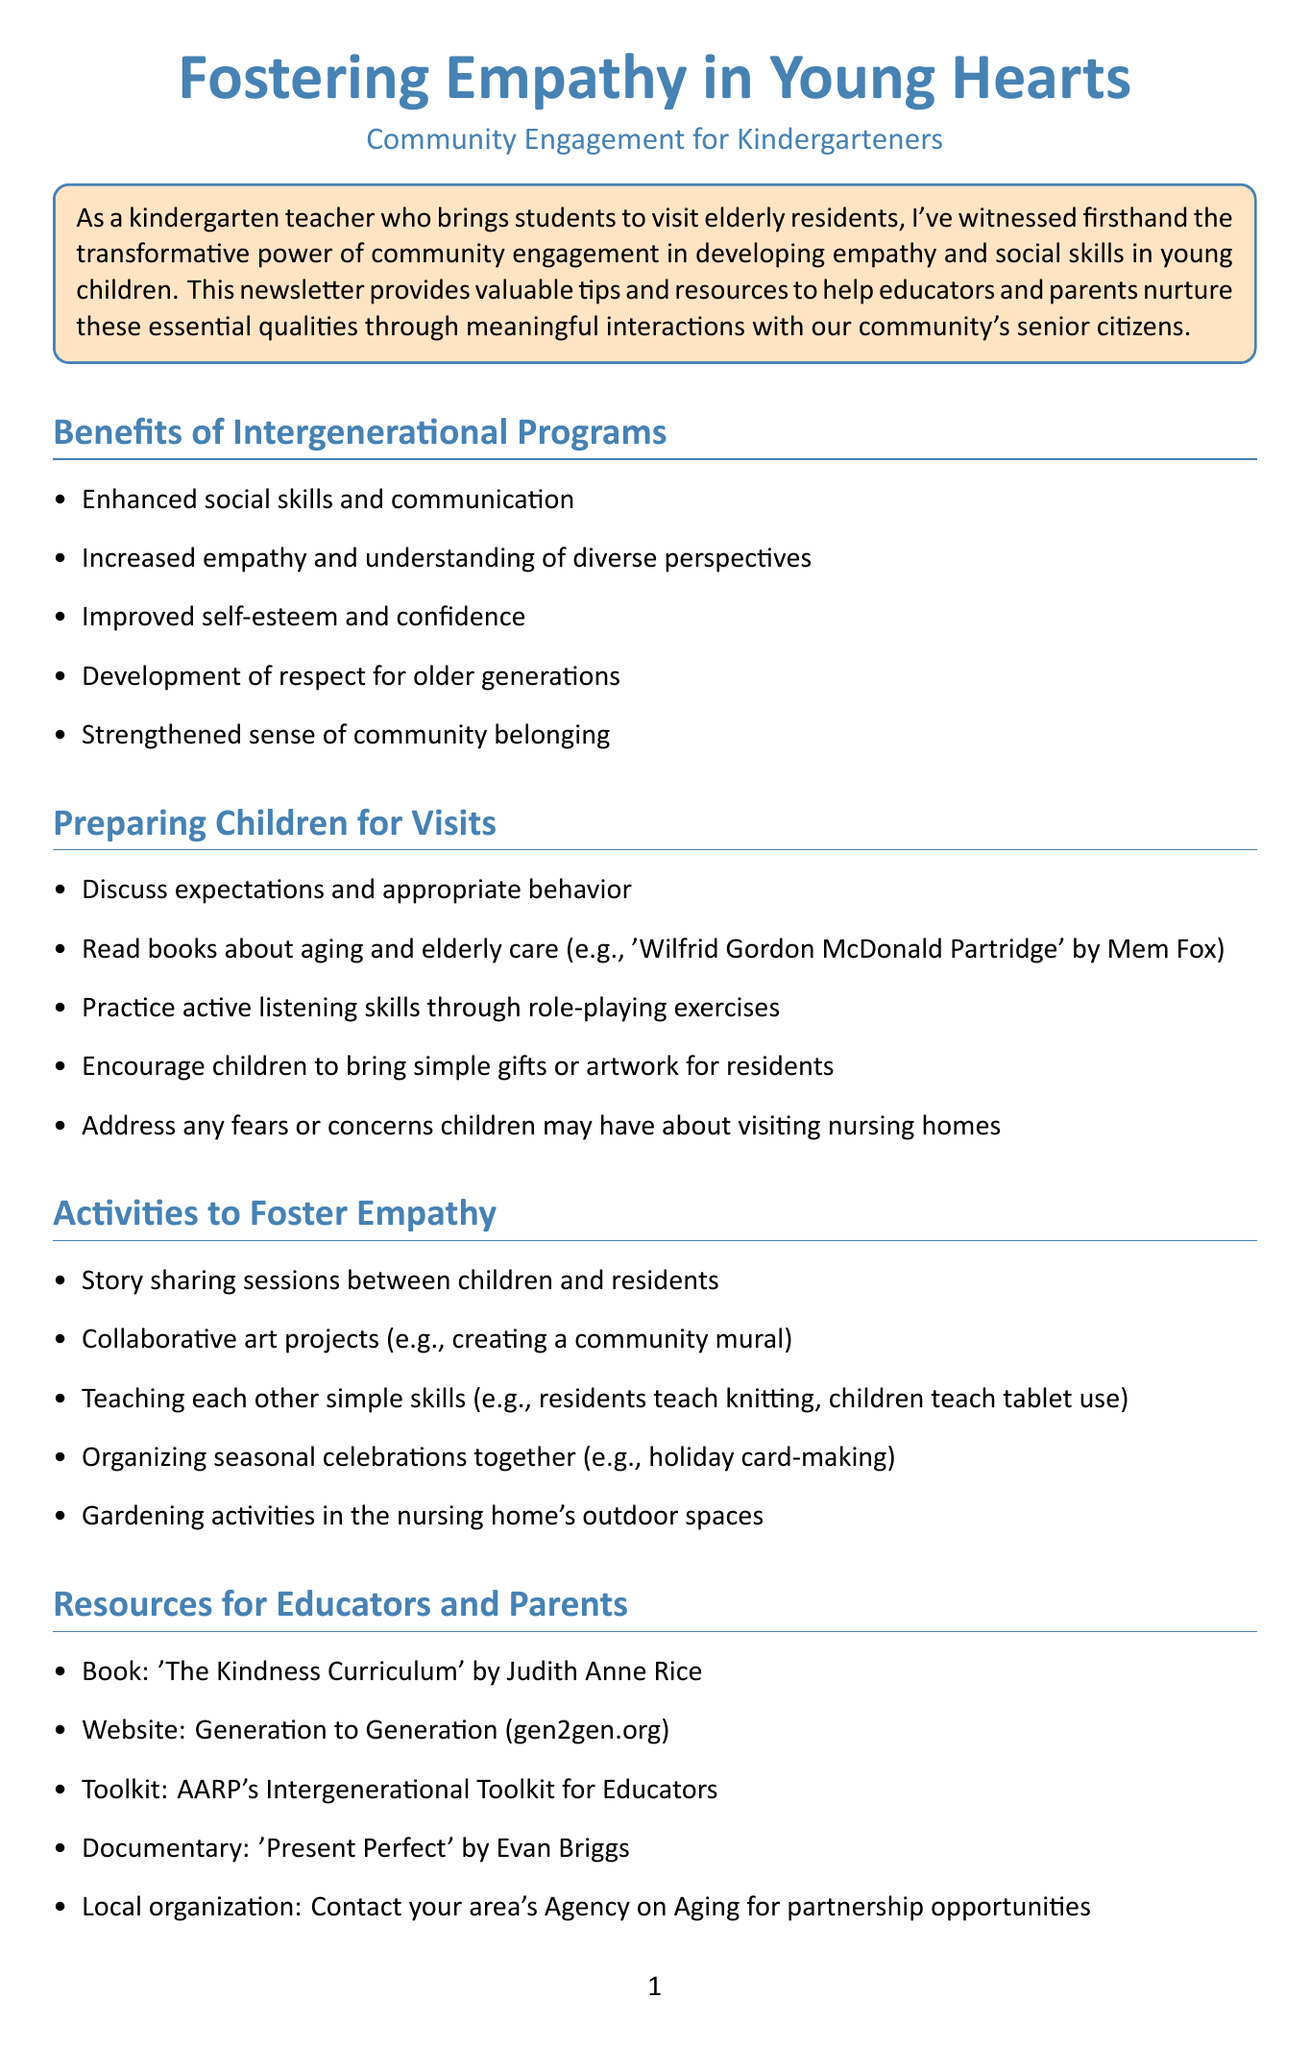What is the title of the newsletter? The title of the newsletter is stated at the beginning of the document, highlighting its focus on empathy and community engagement.
Answer: Fostering Empathy in Young Hearts: Community Engagement for Kindergarteners Who is the target audience of this newsletter? The target audience is indicated in the introduction as those who are involved in nurturing young children's social skills.
Answer: Educators and parents What is one benefit of intergenerational programs listed in the document? The document lists several benefits under the section about intergenerational programs. One of these benefits includes enhanced social skills.
Answer: Enhanced social skills and communication Name one resource provided for educators and parents. The document includes various resources in the section dedicated to educators and parents. One example is a book suggestion.
Answer: Book: 'The Kindness Curriculum' by Judith Anne Rice What activity is suggested for fostering empathy? The activities section offers multiple suggestions, one of which involves collaborating on art projects.
Answer: Collaborative art projects (e.g., creating a community mural) How can children reflect on their experiences after visits? The document outlines several methods for children to process their experiences post-visits, including drawing.
Answer: Draw pictures or write stories about their experiences What is a follow-up action encouraged after community visits? The reflection and follow-up section includes actions such as involving parents by sharing photos and stories.
Answer: Involve parents by sharing photos and stories from visits 